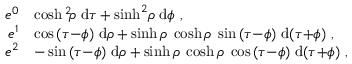<formula> <loc_0><loc_0><loc_500><loc_500>\begin{array} { r l } { e ^ { 0 } } & { \ = \cosh ^ { 2 } \, { \rho } \, d \tau + \sinh ^ { 2 } \, { \rho } \, d \phi \ , } \\ { e ^ { 1 } } & { \ = \cos { ( \tau { - } \phi ) } \, d \rho + \sinh { \rho } \, \cosh { \rho } \, \sin { ( \tau { - } \phi ) } \, d { ( \tau { + } \phi ) } \ , } \\ { e ^ { 2 } } & { \ = - \sin { ( \tau { - } \phi ) } \, d \rho + \sinh { \rho } \, \cosh { \rho } \, \cos { ( \tau { - } \phi ) } \, d { ( \tau { + } \phi ) } \ , } \end{array}</formula> 